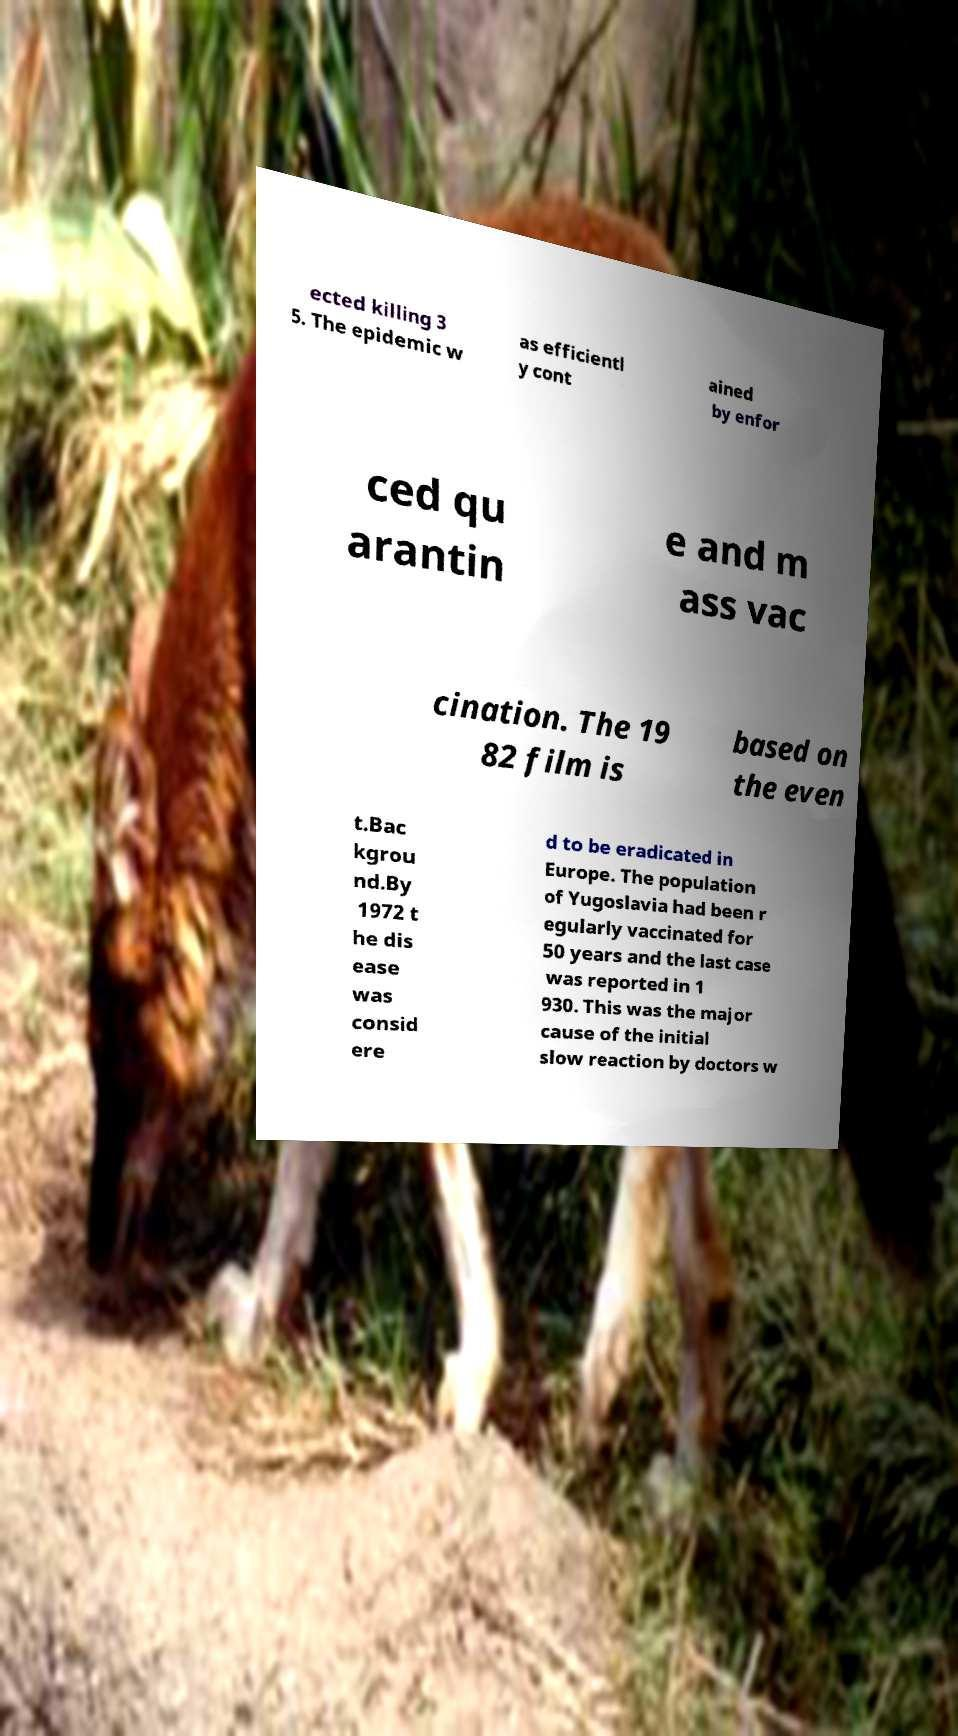I need the written content from this picture converted into text. Can you do that? ected killing 3 5. The epidemic w as efficientl y cont ained by enfor ced qu arantin e and m ass vac cination. The 19 82 film is based on the even t.Bac kgrou nd.By 1972 t he dis ease was consid ere d to be eradicated in Europe. The population of Yugoslavia had been r egularly vaccinated for 50 years and the last case was reported in 1 930. This was the major cause of the initial slow reaction by doctors w 